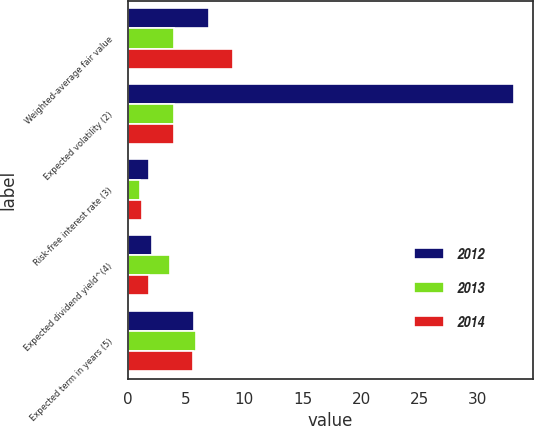Convert chart. <chart><loc_0><loc_0><loc_500><loc_500><stacked_bar_chart><ecel><fcel>Weighted-average fair value<fcel>Expected volatility (2)<fcel>Risk-free interest rate (3)<fcel>Expected dividend yield^(4)<fcel>Expected term in years (5)<nl><fcel>2012<fcel>7<fcel>33.1<fcel>1.8<fcel>2.1<fcel>5.7<nl><fcel>2013<fcel>4<fcel>4<fcel>1.1<fcel>3.6<fcel>5.9<nl><fcel>2014<fcel>9<fcel>4<fcel>1.2<fcel>1.8<fcel>5.6<nl></chart> 